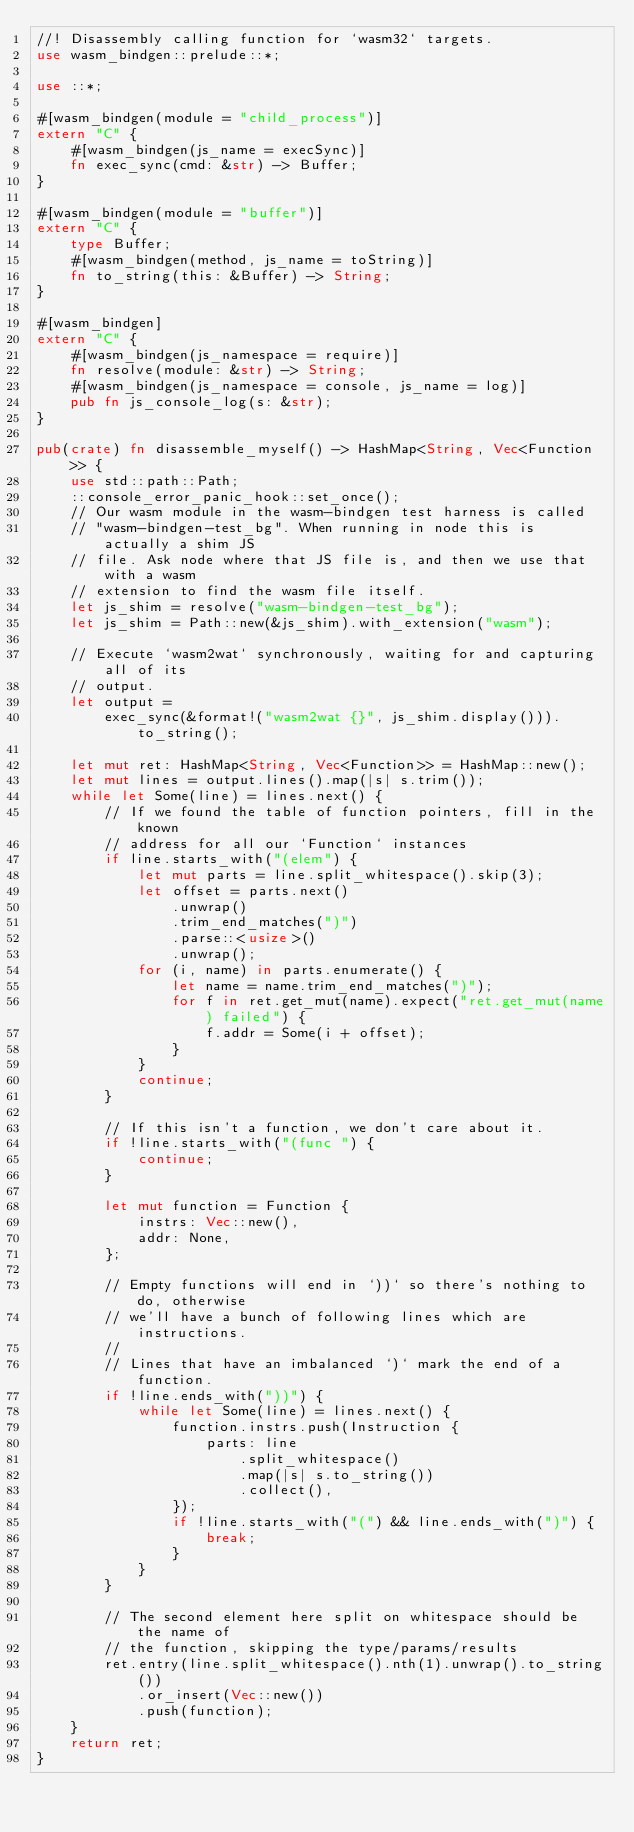Convert code to text. <code><loc_0><loc_0><loc_500><loc_500><_Rust_>//! Disassembly calling function for `wasm32` targets.
use wasm_bindgen::prelude::*;

use ::*;

#[wasm_bindgen(module = "child_process")]
extern "C" {
    #[wasm_bindgen(js_name = execSync)]
    fn exec_sync(cmd: &str) -> Buffer;
}

#[wasm_bindgen(module = "buffer")]
extern "C" {
    type Buffer;
    #[wasm_bindgen(method, js_name = toString)]
    fn to_string(this: &Buffer) -> String;
}

#[wasm_bindgen]
extern "C" {
    #[wasm_bindgen(js_namespace = require)]
    fn resolve(module: &str) -> String;
    #[wasm_bindgen(js_namespace = console, js_name = log)]
    pub fn js_console_log(s: &str);
}

pub(crate) fn disassemble_myself() -> HashMap<String, Vec<Function>> {
    use std::path::Path;
    ::console_error_panic_hook::set_once();
    // Our wasm module in the wasm-bindgen test harness is called
    // "wasm-bindgen-test_bg". When running in node this is actually a shim JS
    // file. Ask node where that JS file is, and then we use that with a wasm
    // extension to find the wasm file itself.
    let js_shim = resolve("wasm-bindgen-test_bg");
    let js_shim = Path::new(&js_shim).with_extension("wasm");

    // Execute `wasm2wat` synchronously, waiting for and capturing all of its
    // output.
    let output =
        exec_sync(&format!("wasm2wat {}", js_shim.display())).to_string();

    let mut ret: HashMap<String, Vec<Function>> = HashMap::new();
    let mut lines = output.lines().map(|s| s.trim());
    while let Some(line) = lines.next() {
        // If we found the table of function pointers, fill in the known
        // address for all our `Function` instances
        if line.starts_with("(elem") {
            let mut parts = line.split_whitespace().skip(3);
            let offset = parts.next()
                .unwrap()
                .trim_end_matches(")")
                .parse::<usize>()
                .unwrap();
            for (i, name) in parts.enumerate() {
                let name = name.trim_end_matches(")");
                for f in ret.get_mut(name).expect("ret.get_mut(name) failed") {
                    f.addr = Some(i + offset);
                }
            }
            continue;
        }

        // If this isn't a function, we don't care about it.
        if !line.starts_with("(func ") {
            continue;
        }

        let mut function = Function {
            instrs: Vec::new(),
            addr: None,
        };

        // Empty functions will end in `))` so there's nothing to do, otherwise
        // we'll have a bunch of following lines which are instructions.
        //
        // Lines that have an imbalanced `)` mark the end of a function.
        if !line.ends_with("))") {
            while let Some(line) = lines.next() {
                function.instrs.push(Instruction {
                    parts: line
                        .split_whitespace()
                        .map(|s| s.to_string())
                        .collect(),
                });
                if !line.starts_with("(") && line.ends_with(")") {
                    break;
                }
            }
        }

        // The second element here split on whitespace should be the name of
        // the function, skipping the type/params/results
        ret.entry(line.split_whitespace().nth(1).unwrap().to_string())
            .or_insert(Vec::new())
            .push(function);
    }
    return ret;
}
</code> 